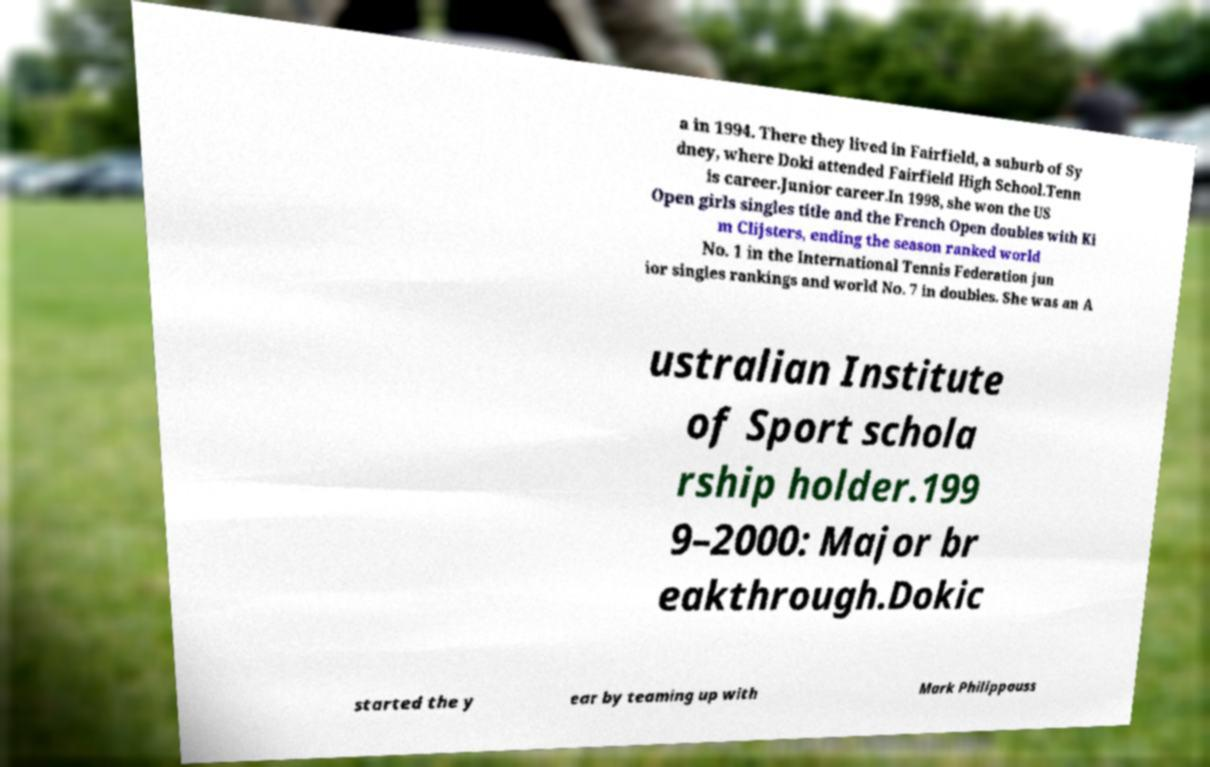Can you read and provide the text displayed in the image?This photo seems to have some interesting text. Can you extract and type it out for me? a in 1994. There they lived in Fairfield, a suburb of Sy dney, where Doki attended Fairfield High School.Tenn is career.Junior career.In 1998, she won the US Open girls singles title and the French Open doubles with Ki m Clijsters, ending the season ranked world No. 1 in the International Tennis Federation jun ior singles rankings and world No. 7 in doubles. She was an A ustralian Institute of Sport schola rship holder.199 9–2000: Major br eakthrough.Dokic started the y ear by teaming up with Mark Philippouss 